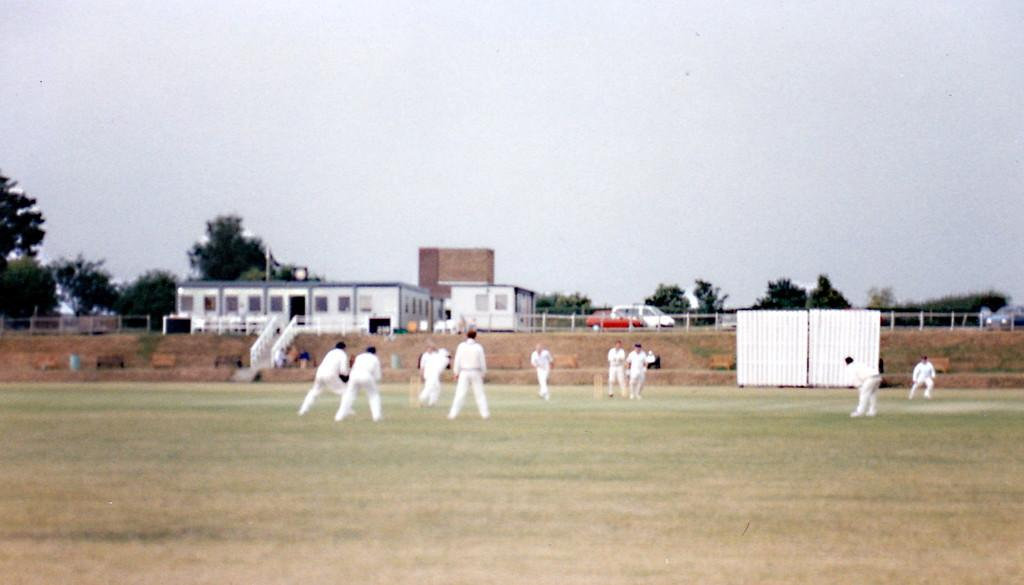What sport are the people playing in the image? The people are playing cricket in the image. Where are some of the people located in the image? There are people near the steps and on the road in the image. What type of barrier is present in the image? There is a fence in the image. What type of structures can be seen in the image? There are houses in the image. What type of vegetation is present in the image? There are trees in the image. What part of the natural environment is visible in the image? The sky is visible in the image. What type of bone is visible in the image? There is no bone present in the image. How many boys are playing cricket in the image? The image does not specify the gender of the players, so it cannot be determined if there are any boys playing cricket. 